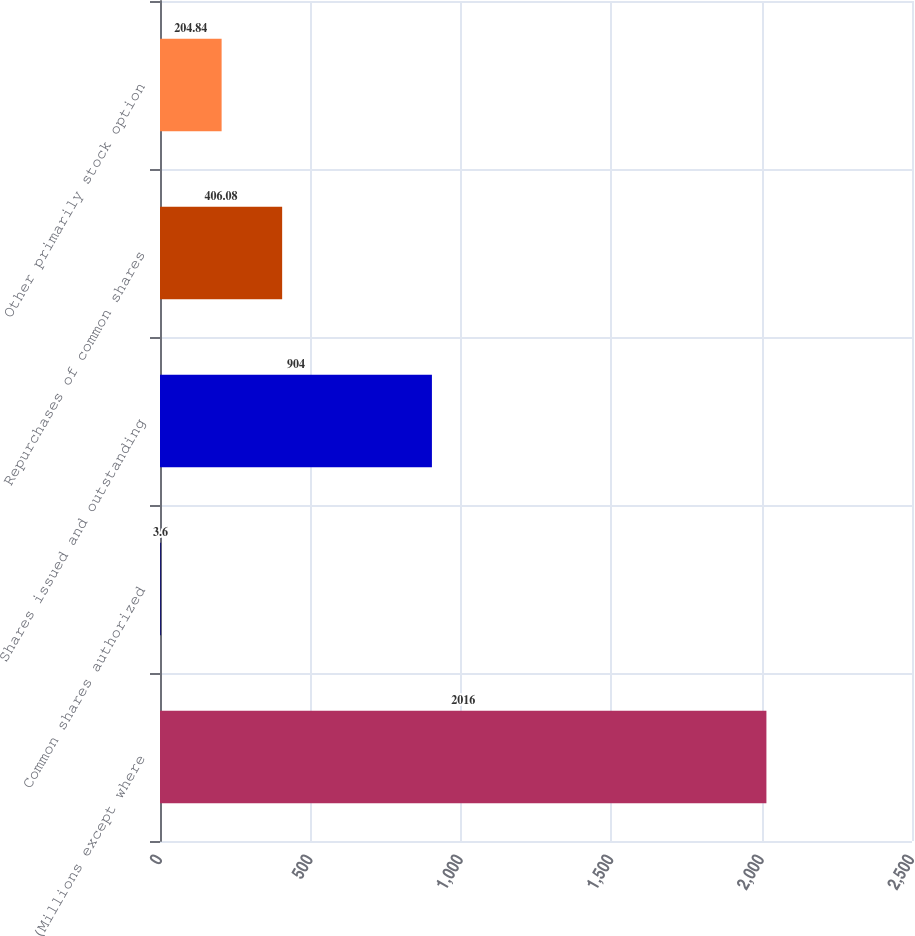Convert chart. <chart><loc_0><loc_0><loc_500><loc_500><bar_chart><fcel>(Millions except where<fcel>Common shares authorized<fcel>Shares issued and outstanding<fcel>Repurchases of common shares<fcel>Other primarily stock option<nl><fcel>2016<fcel>3.6<fcel>904<fcel>406.08<fcel>204.84<nl></chart> 